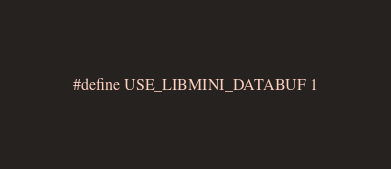<code> <loc_0><loc_0><loc_500><loc_500><_C_>
#define USE_LIBMINI_DATABUF 1
</code> 